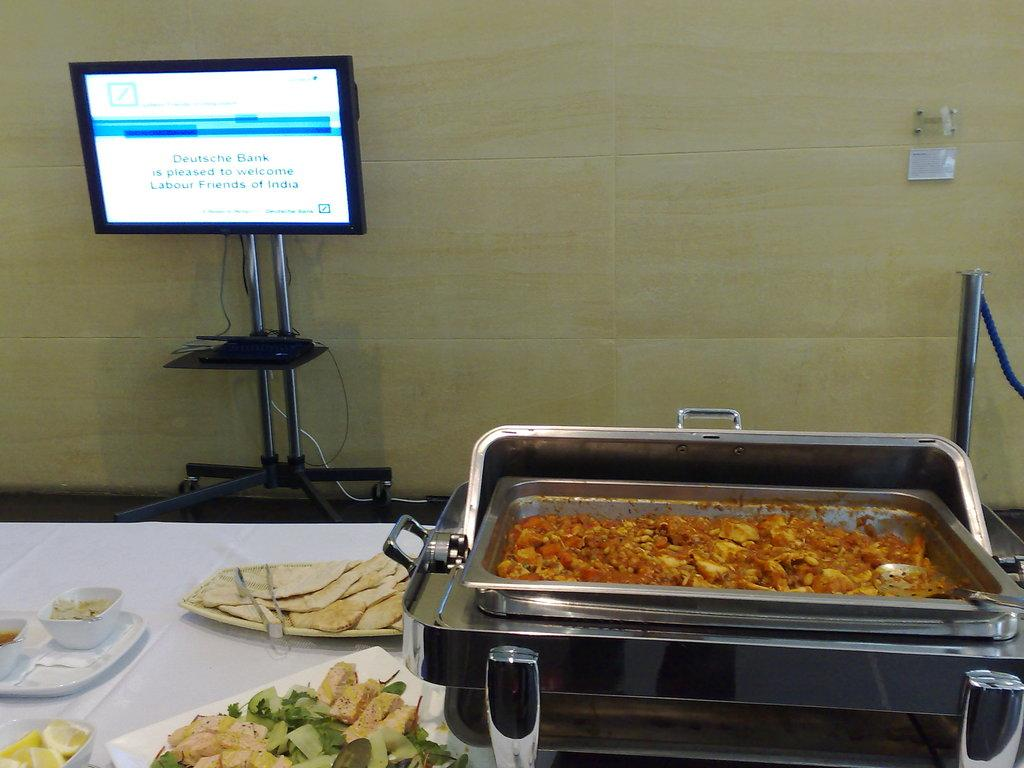<image>
Offer a succinct explanation of the picture presented. A buffet table with a computer screen that says "Deutsche Bank is pleased to welcome Labour Friends of India". 